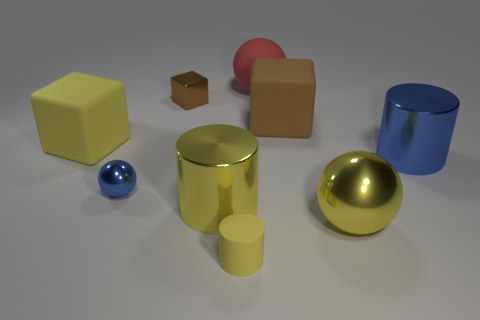There is a small thing that is behind the yellow rubber cylinder and in front of the small cube; what shape is it?
Provide a succinct answer. Sphere. There is a brown object that is the same material as the small cylinder; what shape is it?
Your answer should be very brief. Cube. What material is the ball that is behind the blue metallic ball?
Offer a terse response. Rubber. There is a cylinder behind the big yellow metal cylinder; is its size the same as the matte block that is right of the small blue metal ball?
Provide a succinct answer. Yes. The large rubber ball has what color?
Ensure brevity in your answer.  Red. Is the shape of the yellow rubber thing that is behind the small rubber object the same as  the red rubber thing?
Your answer should be very brief. No. What is the material of the red sphere?
Your answer should be very brief. Rubber. What is the shape of the red matte thing that is the same size as the brown rubber thing?
Ensure brevity in your answer.  Sphere. Are there any big rubber objects of the same color as the matte ball?
Give a very brief answer. No. There is a small metallic cube; does it have the same color as the big sphere right of the large red rubber thing?
Your answer should be very brief. No. 